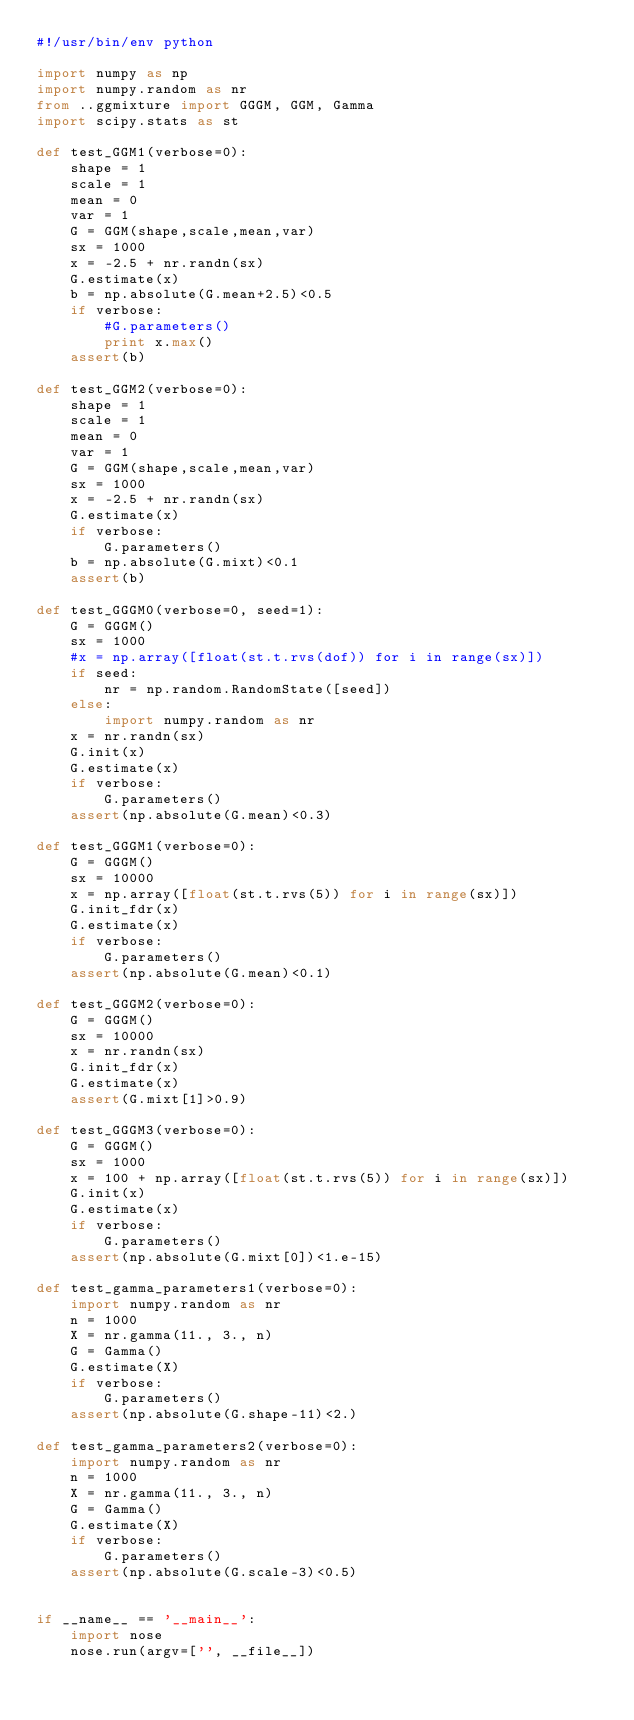<code> <loc_0><loc_0><loc_500><loc_500><_Python_>#!/usr/bin/env python

import numpy as np
import numpy.random as nr
from ..ggmixture import GGGM, GGM, Gamma
import scipy.stats as st

def test_GGM1(verbose=0):
    shape = 1 
    scale = 1
    mean = 0
    var = 1
    G = GGM(shape,scale,mean,var)
    sx = 1000
    x = -2.5 + nr.randn(sx)
    G.estimate(x)
    b = np.absolute(G.mean+2.5)<0.5
    if verbose:
        #G.parameters()
        print x.max()
    assert(b)

def test_GGM2(verbose=0):
    shape = 1 
    scale = 1
    mean = 0
    var = 1
    G = GGM(shape,scale,mean,var)
    sx = 1000
    x = -2.5 + nr.randn(sx)
    G.estimate(x)
    if verbose:
        G.parameters()
    b = np.absolute(G.mixt)<0.1
    assert(b)

def test_GGGM0(verbose=0, seed=1):
    G = GGGM()
    sx = 1000
    #x = np.array([float(st.t.rvs(dof)) for i in range(sx)])
    if seed:
        nr = np.random.RandomState([seed])
    else:
        import numpy.random as nr
    x = nr.randn(sx)
    G.init(x)
    G.estimate(x)
    if verbose:
        G.parameters()
    assert(np.absolute(G.mean)<0.3)

def test_GGGM1(verbose=0):
    G = GGGM()
    sx = 10000
    x = np.array([float(st.t.rvs(5)) for i in range(sx)])
    G.init_fdr(x)
    G.estimate(x)
    if verbose:
        G.parameters()
    assert(np.absolute(G.mean)<0.1)
    
def test_GGGM2(verbose=0):
    G = GGGM()
    sx = 10000
    x = nr.randn(sx)
    G.init_fdr(x)
    G.estimate(x)
    assert(G.mixt[1]>0.9)

def test_GGGM3(verbose=0):
    G = GGGM()
    sx = 1000
    x = 100 + np.array([float(st.t.rvs(5)) for i in range(sx)])
    G.init(x)
    G.estimate(x)
    if verbose:
        G.parameters()
    assert(np.absolute(G.mixt[0])<1.e-15)

def test_gamma_parameters1(verbose=0):
    import numpy.random as nr
    n = 1000
    X = nr.gamma(11., 3., n)
    G = Gamma()
    G.estimate(X)
    if verbose:
        G.parameters()
    assert(np.absolute(G.shape-11)<2.)

def test_gamma_parameters2(verbose=0):
    import numpy.random as nr
    n = 1000
    X = nr.gamma(11., 3., n)
    G = Gamma()
    G.estimate(X)
    if verbose:
        G.parameters()
    assert(np.absolute(G.scale-3)<0.5)


if __name__ == '__main__':
    import nose
    nose.run(argv=['', __file__])


</code> 